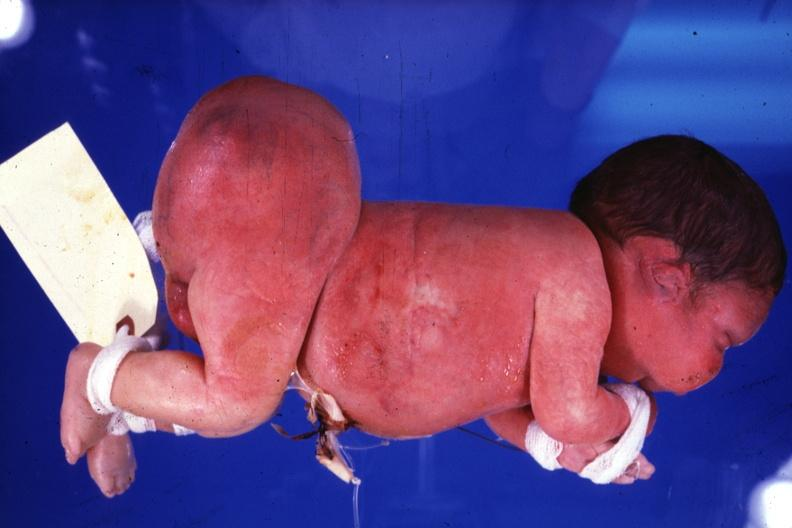how does this image show lateral view of body?
Answer the question using a single word or phrase. With grossly enlarged buttocks area 